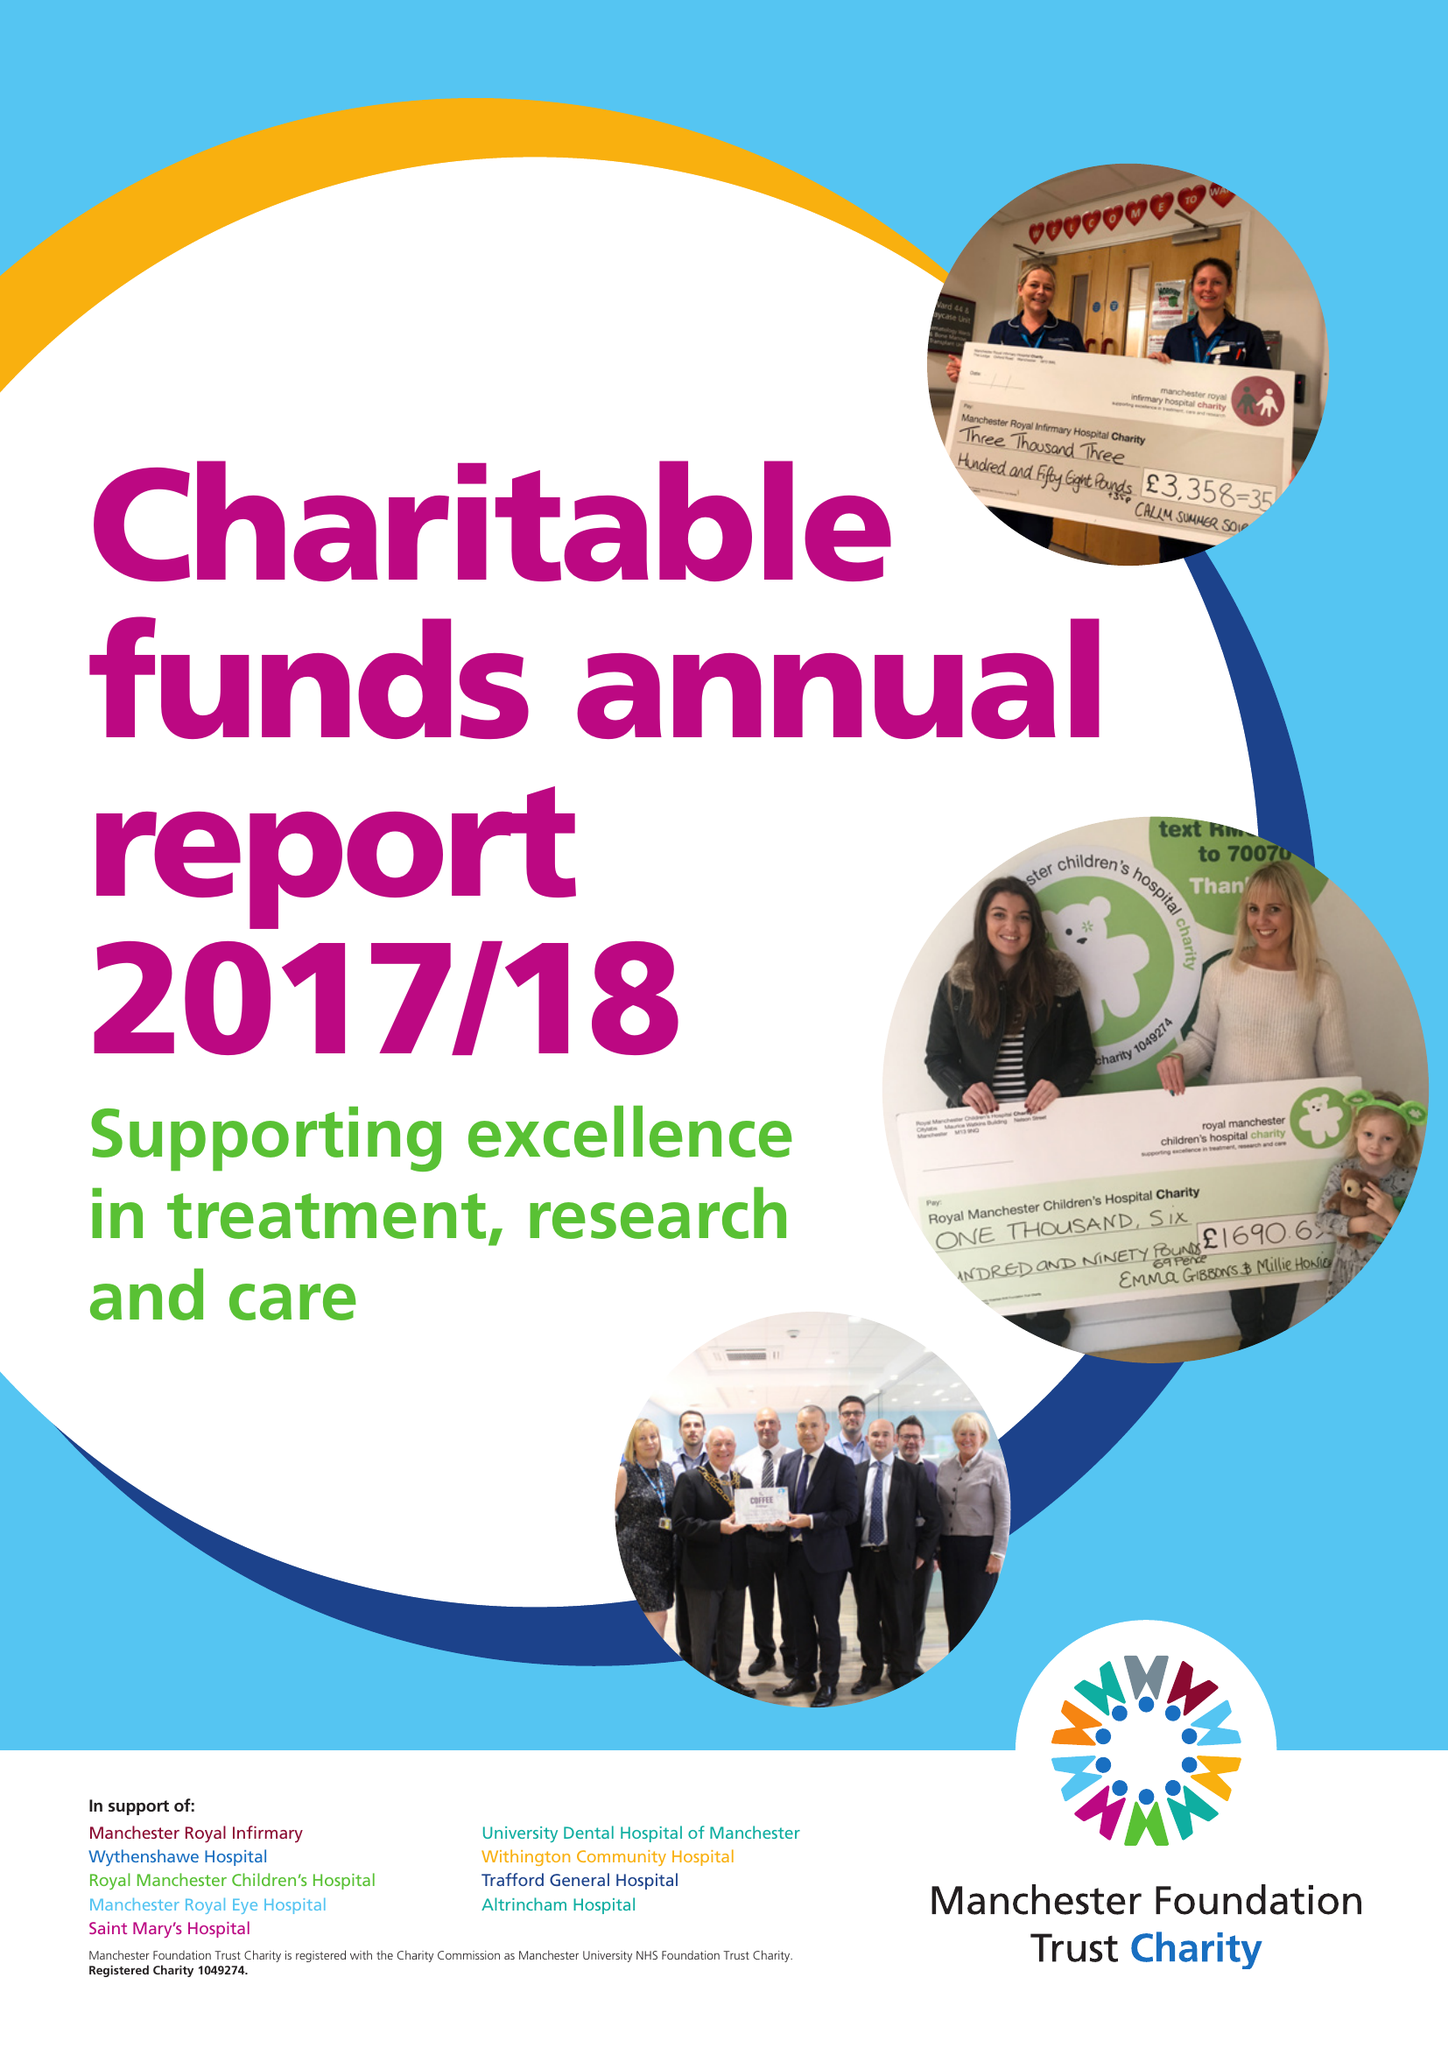What is the value for the report_date?
Answer the question using a single word or phrase. 2018-03-31 